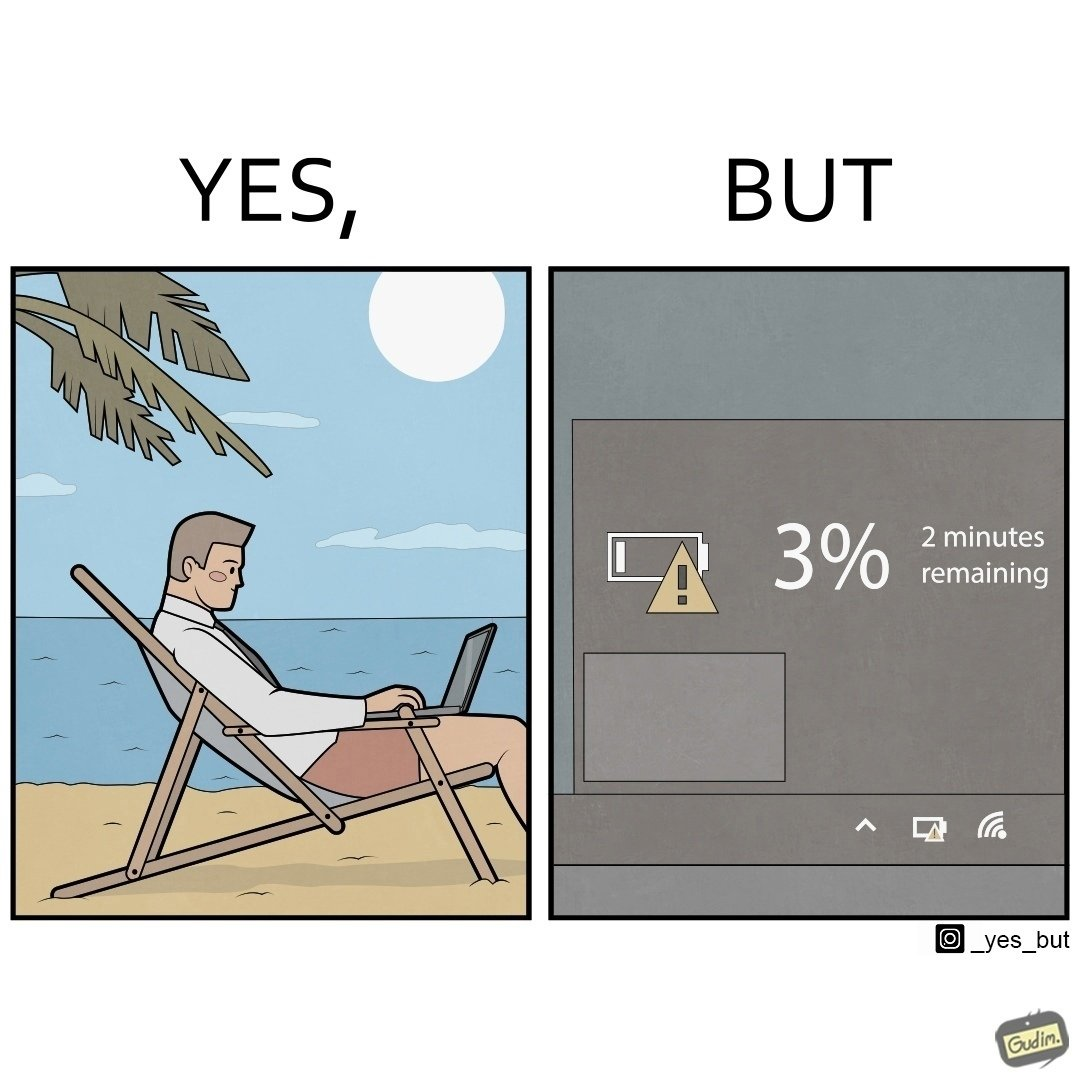What do you see in each half of this image? In the left part of the image: A person sitting in a chair in a beach by the sea shore while working on a laptop. In the right part of the image: Low charge of battery, showing 3% charge, and an estimated time of 2 minutes remaining until the device switches off due to lack of battery charge. 